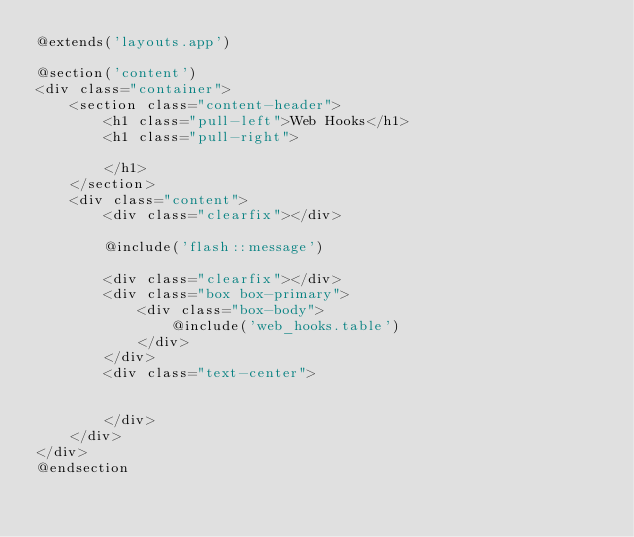<code> <loc_0><loc_0><loc_500><loc_500><_PHP_>@extends('layouts.app')

@section('content')
<div class="container">
    <section class="content-header">
        <h1 class="pull-left">Web Hooks</h1>
        <h1 class="pull-right">

        </h1>
    </section>
    <div class="content">
        <div class="clearfix"></div>

        @include('flash::message')

        <div class="clearfix"></div>
        <div class="box box-primary">
            <div class="box-body">
                @include('web_hooks.table')
            </div>
        </div>
        <div class="text-center">


        </div>
    </div>
</div>
@endsection</code> 